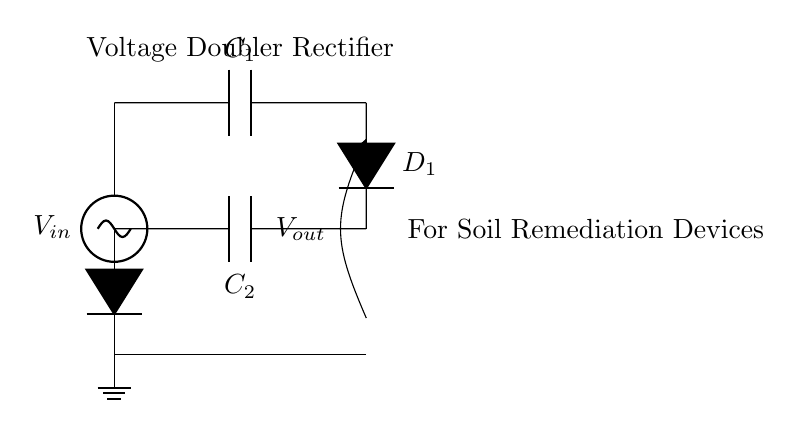What components are present in the circuit? The components visible in the circuit diagram are two capacitors labeled C1 and C2, and two diodes labeled D1 and D2. These components indicate that a voltage doubler rectifier circuit is constructed.
Answer: capacitors, diodes What is the function of the diodes in this circuit? The diodes in a rectifier circuit permit current to flow only in one direction, allowing the circuit to convert alternating current (AC) input into direct current (DC) output, which is essential for effective operation of soil remediation devices.
Answer: convert current direction What is the output voltage of this voltage doubler circuit? The voltage output of a voltage doubler rectifier is typically twice the input voltage, meaning if the input voltage is V, the output will be approximately 2V. This capability enhances the efficiency of soil remediation devices that require higher voltages.
Answer: twice the input voltage How many voltage sources are in the circuit? There is one voltage source indicated at the top of the circuit diagram, labeled Vin. This single voltage source is a characteristic of this particular rectifier configuration.
Answer: one voltage source Why are capacitors used in this circuit? Capacitors are used in this voltage doubler rectifier circuit to store energy and help smooth the output voltage. They charge when the diodes conduct and then discharge to provide a steady voltage output, playing a crucial role for the performance of soil remediation devices.
Answer: store energy and smooth output What is the positioning of the capacitors in the circuit? The capacitors are positioned such that C1 is connected directly to the input voltage source and D1, while C2 is connected to D1 and the output. This arrangement allows for the doubling of the voltage in conjunction with the diodes.
Answer: C1 at input; C2 at output What does the labeling "For Soil Remediation Devices" indicate in the circuit? The labeling indicates the intended application and significance of the circuit, suggesting that it is designed specifically to enhance the performance and efficiency of devices utilized for soil remediation in affected neighborhoods.
Answer: intended application 